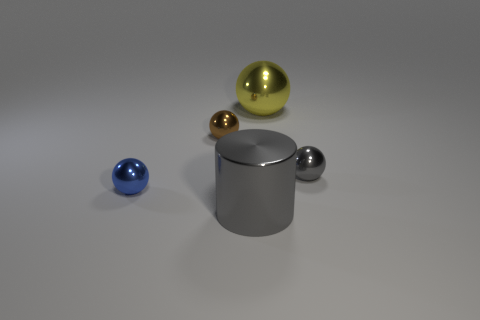Does the object that is right of the big yellow sphere have the same color as the large metal object that is to the left of the yellow metallic object?
Give a very brief answer. Yes. Is the number of gray things greater than the number of big yellow spheres?
Provide a short and direct response. Yes. What number of small metallic spheres have the same color as the large cylinder?
Keep it short and to the point. 1. There is a big metal thing that is the same shape as the tiny gray object; what color is it?
Your answer should be compact. Yellow. How big is the yellow ball?
Your answer should be very brief. Large. What is the size of the gray object that is the same shape as the blue object?
Make the answer very short. Small. How many large yellow objects are on the right side of the small blue thing?
Your answer should be compact. 1. What is the color of the large thing in front of the metallic thing to the left of the tiny brown thing?
Provide a short and direct response. Gray. Is there anything else that is the same shape as the big gray shiny thing?
Offer a terse response. No. Are there an equal number of gray shiny objects that are behind the yellow metal thing and tiny brown shiny spheres that are right of the small brown object?
Make the answer very short. Yes. 